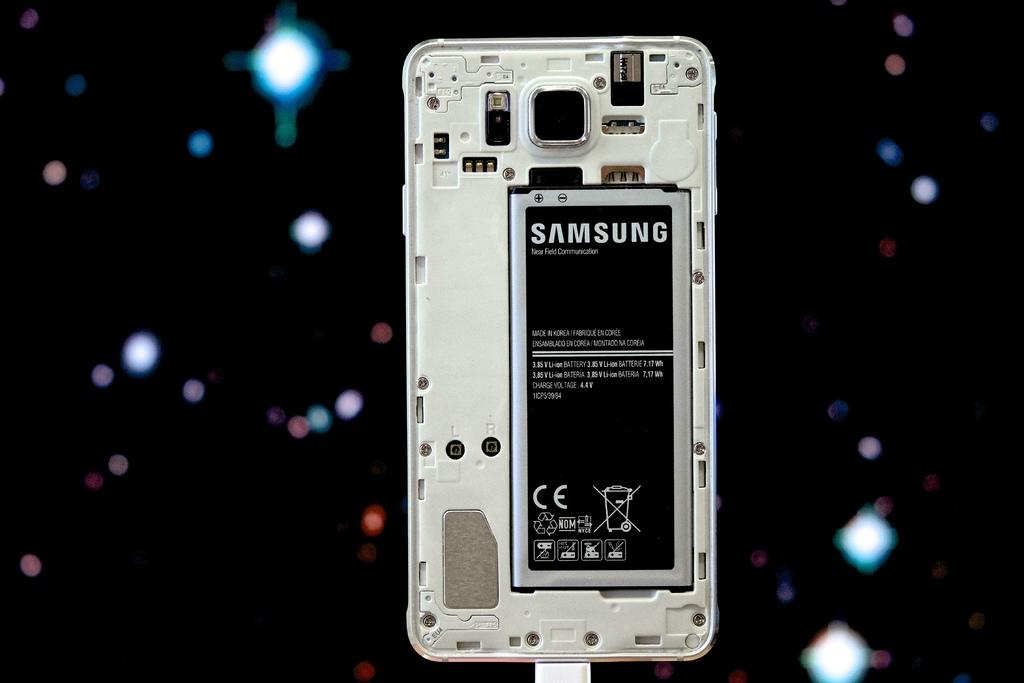<image>
Relay a brief, clear account of the picture shown. A Samsung phone is open fron the back and the battery is showing. 